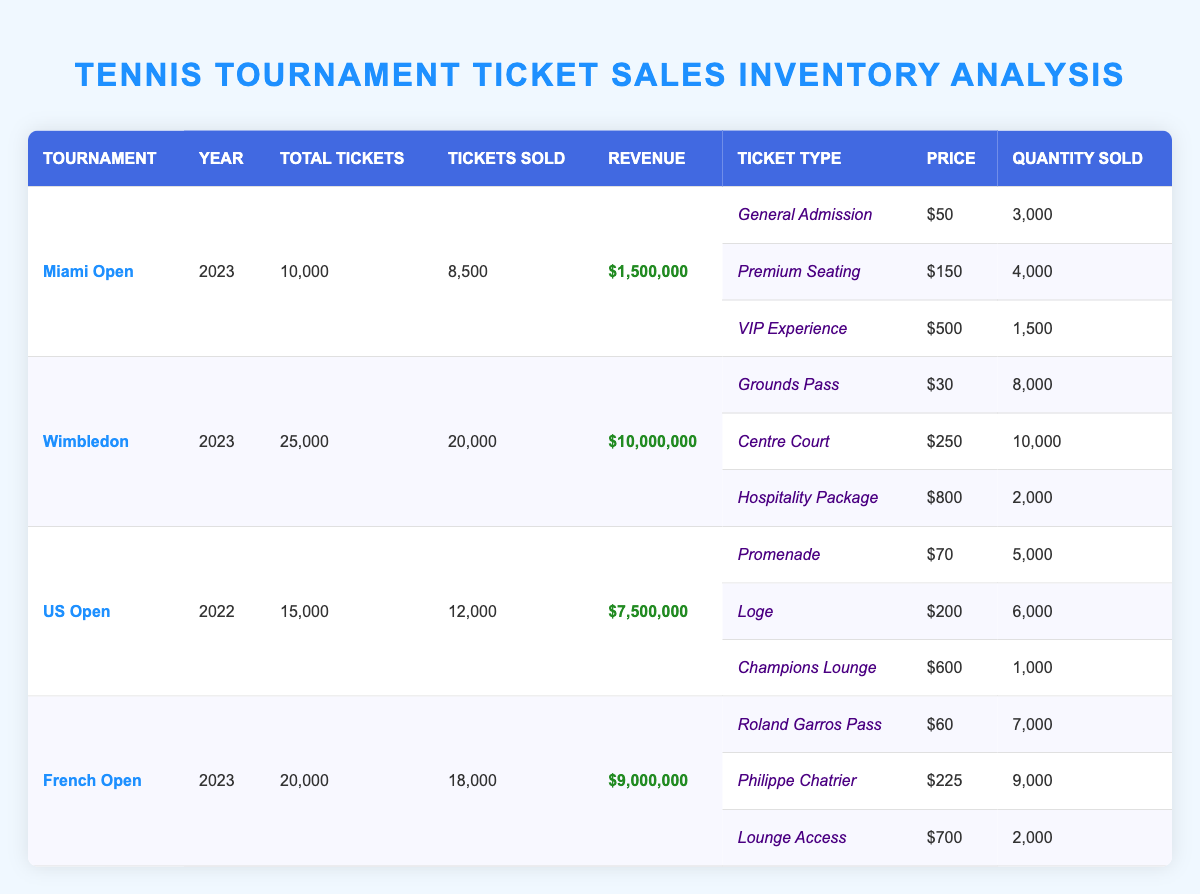What is the total revenue generated from the Wimbledon tournament in 2023? According to the table under the Wimbledon row highlighted for 2023, the revenue generated is listed as $10,000,000.
Answer: $10,000,000 How many tickets were sold for the French Open in 2023? The table shows that for the French Open tournament in 2023, the total tickets sold is indicated as 18,000.
Answer: 18,000 Which ticket type generated the highest revenue for the US Open in 2022? To find the highest revenue-generating ticket type for the US Open, we analyze the quantity sold multiplied by the price for each type: Promenade (5000 x $70 = $350,000), Loge (6000 x $200 = $1,200,000), and Champions Lounge (1000 x $600 = $600,000). Loge has the highest revenue of $1,200,000.
Answer: Loge Is it true that more than 20,000 tickets were sold for any tournament in 2023? Checking the number of tickets sold for each tournament in 2023, we see that Miami Open had 8,500, Wimbledon had 20,000, and French Open had 18,000. None exceed 20,000 tickets sold.
Answer: No What is the average price of all ticket types sold at the Miami Open? To calculate the average price for Miami Open, we add the prices of each ticket type multiplied by the quantity sold: (General Admission: $50 x 3000) + (Premium Seating: $150 x 4000) + (VIP Experience: $500 x 1500) = $150,000 + $600,000 + $750,000 = $1,500,000. The total number of tickets sold is 8,500. Therefore, average price = $1,500,000 / 8,500 = $176.47.
Answer: $176.47 How many more tickets were sold at Wimbledon than at the French Open? From the table, we note that Wimbledon had 20,000 tickets sold while the French Open had 18,000. The difference is calculated as 20,000 - 18,000 = 2,000.
Answer: 2,000 What was the total number of tickets available across all tournaments in 2023? Looking at the inventory for 2023, we add: Miami Open (10,000) + Wimbledon (25,000) + French Open (20,000) = 55,000 total tickets available for these three tournaments.
Answer: 55,000 Did the VIP Experience ticket type sell more tickets than the Premium Seating at the Miami Open? Reviewing the table, VIP Experience sold 1,500 tickets, while Premium Seating sold 4,000 tickets. Since 1,500 is less than 4,000, the answer is no.
Answer: No 